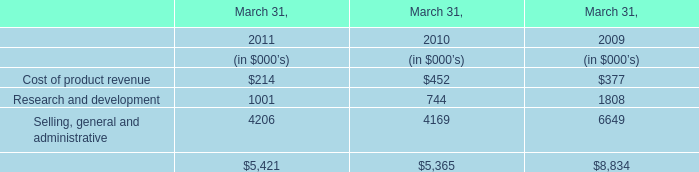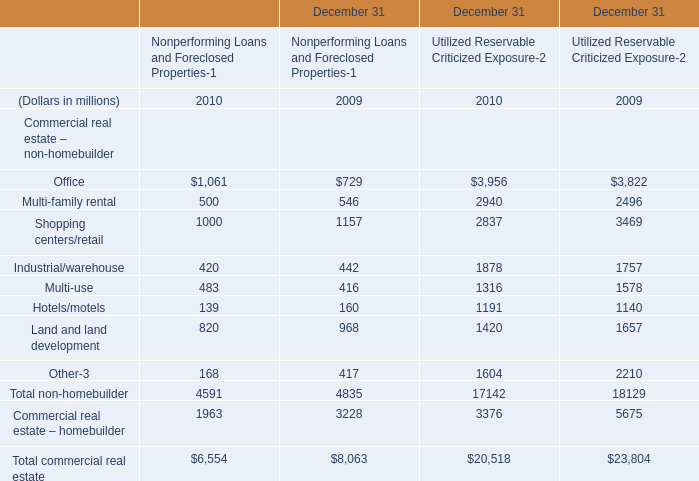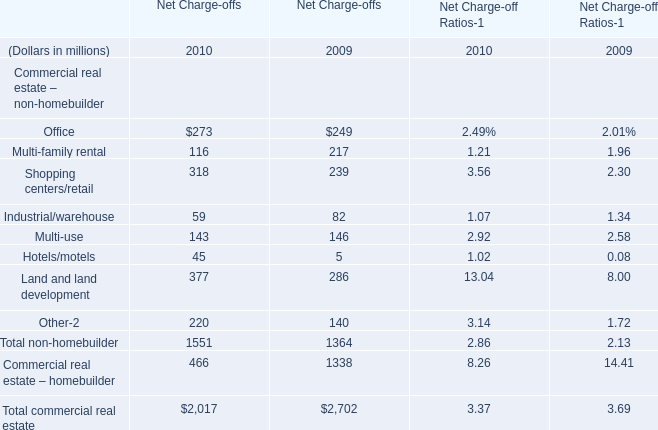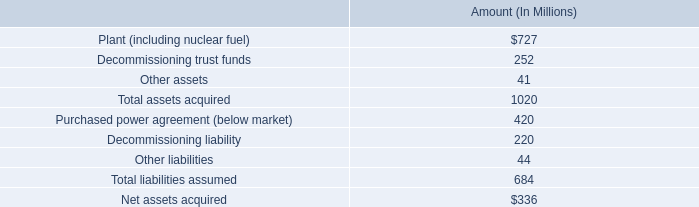In what year is Office greater than1for Net Charge-offs? 
Answer: 2009 2010. 